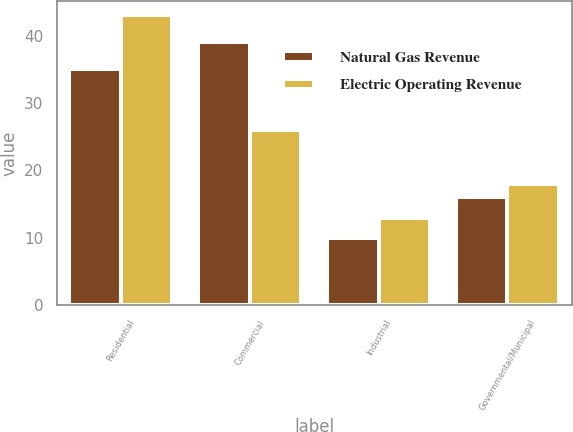Convert chart to OTSL. <chart><loc_0><loc_0><loc_500><loc_500><stacked_bar_chart><ecel><fcel>Residential<fcel>Commercial<fcel>Industrial<fcel>Governmental/Municipal<nl><fcel>Natural Gas Revenue<fcel>35<fcel>39<fcel>10<fcel>16<nl><fcel>Electric Operating Revenue<fcel>43<fcel>26<fcel>13<fcel>18<nl></chart> 